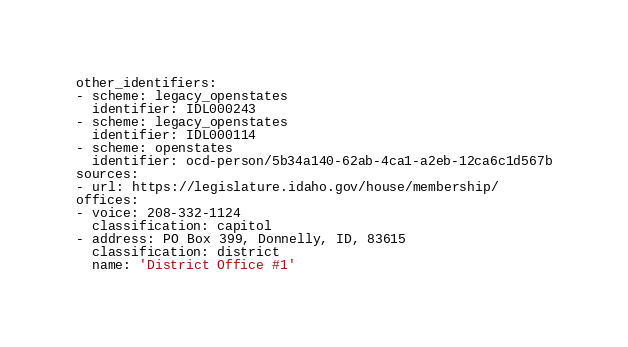Convert code to text. <code><loc_0><loc_0><loc_500><loc_500><_YAML_>other_identifiers:
- scheme: legacy_openstates
  identifier: IDL000243
- scheme: legacy_openstates
  identifier: IDL000114
- scheme: openstates
  identifier: ocd-person/5b34a140-62ab-4ca1-a2eb-12ca6c1d567b
sources:
- url: https://legislature.idaho.gov/house/membership/
offices:
- voice: 208-332-1124
  classification: capitol
- address: PO Box 399, Donnelly, ID, 83615
  classification: district
  name: 'District Office #1'
</code> 